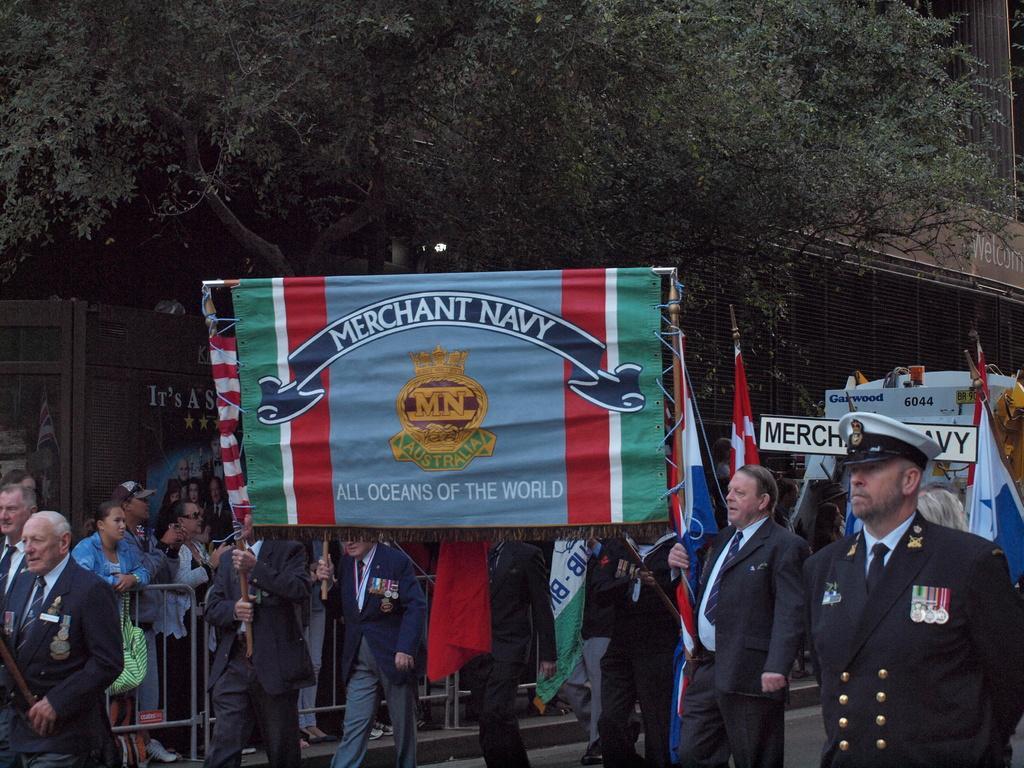Please provide a concise description of this image. In this image we can see a group of people standing. In that two men are holding a banner with the sticks and some are holding the flags. We can also see a fence, a board with some text on it, a building with a metal grill and a tree. 